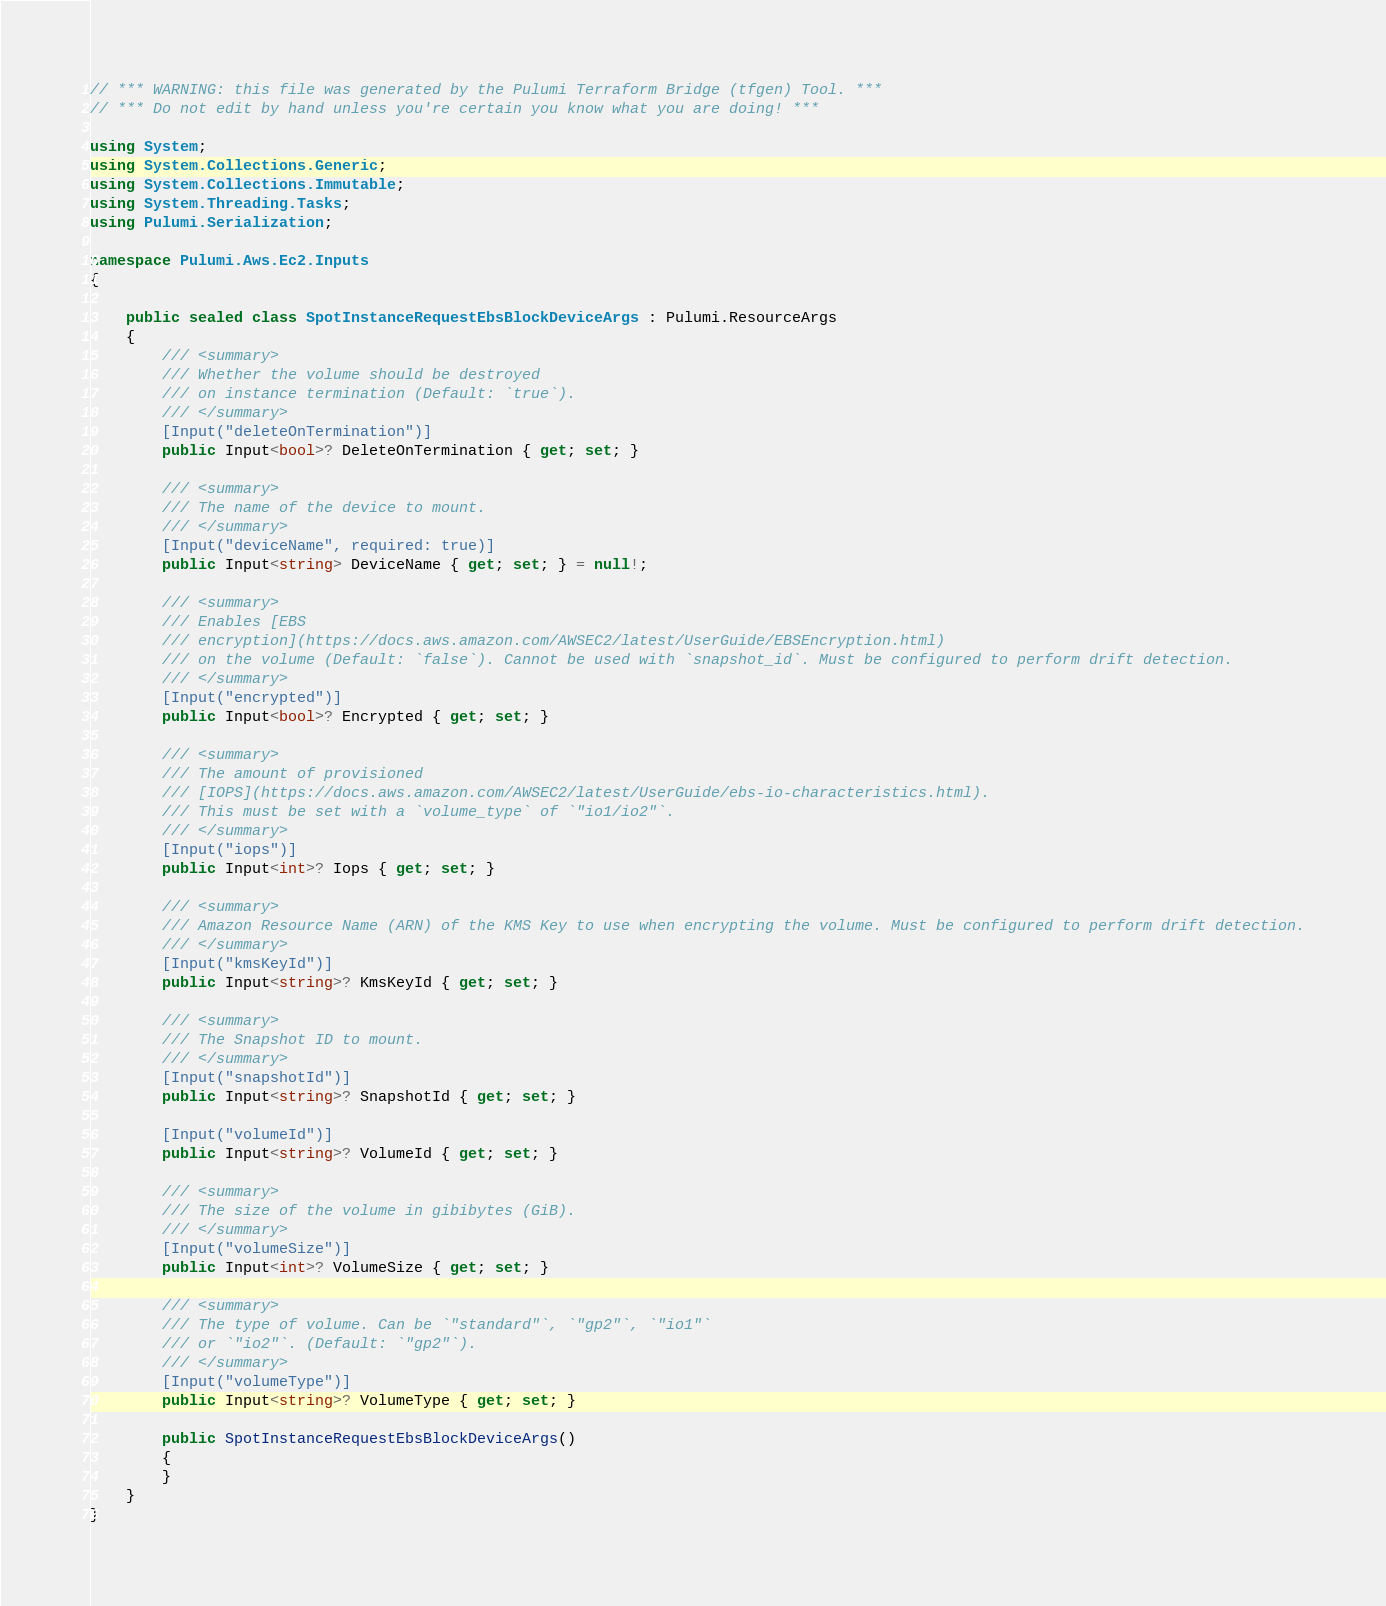Convert code to text. <code><loc_0><loc_0><loc_500><loc_500><_C#_>// *** WARNING: this file was generated by the Pulumi Terraform Bridge (tfgen) Tool. ***
// *** Do not edit by hand unless you're certain you know what you are doing! ***

using System;
using System.Collections.Generic;
using System.Collections.Immutable;
using System.Threading.Tasks;
using Pulumi.Serialization;

namespace Pulumi.Aws.Ec2.Inputs
{

    public sealed class SpotInstanceRequestEbsBlockDeviceArgs : Pulumi.ResourceArgs
    {
        /// <summary>
        /// Whether the volume should be destroyed
        /// on instance termination (Default: `true`).
        /// </summary>
        [Input("deleteOnTermination")]
        public Input<bool>? DeleteOnTermination { get; set; }

        /// <summary>
        /// The name of the device to mount.
        /// </summary>
        [Input("deviceName", required: true)]
        public Input<string> DeviceName { get; set; } = null!;

        /// <summary>
        /// Enables [EBS
        /// encryption](https://docs.aws.amazon.com/AWSEC2/latest/UserGuide/EBSEncryption.html)
        /// on the volume (Default: `false`). Cannot be used with `snapshot_id`. Must be configured to perform drift detection.
        /// </summary>
        [Input("encrypted")]
        public Input<bool>? Encrypted { get; set; }

        /// <summary>
        /// The amount of provisioned
        /// [IOPS](https://docs.aws.amazon.com/AWSEC2/latest/UserGuide/ebs-io-characteristics.html).
        /// This must be set with a `volume_type` of `"io1/io2"`.
        /// </summary>
        [Input("iops")]
        public Input<int>? Iops { get; set; }

        /// <summary>
        /// Amazon Resource Name (ARN) of the KMS Key to use when encrypting the volume. Must be configured to perform drift detection.
        /// </summary>
        [Input("kmsKeyId")]
        public Input<string>? KmsKeyId { get; set; }

        /// <summary>
        /// The Snapshot ID to mount.
        /// </summary>
        [Input("snapshotId")]
        public Input<string>? SnapshotId { get; set; }

        [Input("volumeId")]
        public Input<string>? VolumeId { get; set; }

        /// <summary>
        /// The size of the volume in gibibytes (GiB).
        /// </summary>
        [Input("volumeSize")]
        public Input<int>? VolumeSize { get; set; }

        /// <summary>
        /// The type of volume. Can be `"standard"`, `"gp2"`, `"io1"`
        /// or `"io2"`. (Default: `"gp2"`).
        /// </summary>
        [Input("volumeType")]
        public Input<string>? VolumeType { get; set; }

        public SpotInstanceRequestEbsBlockDeviceArgs()
        {
        }
    }
}
</code> 